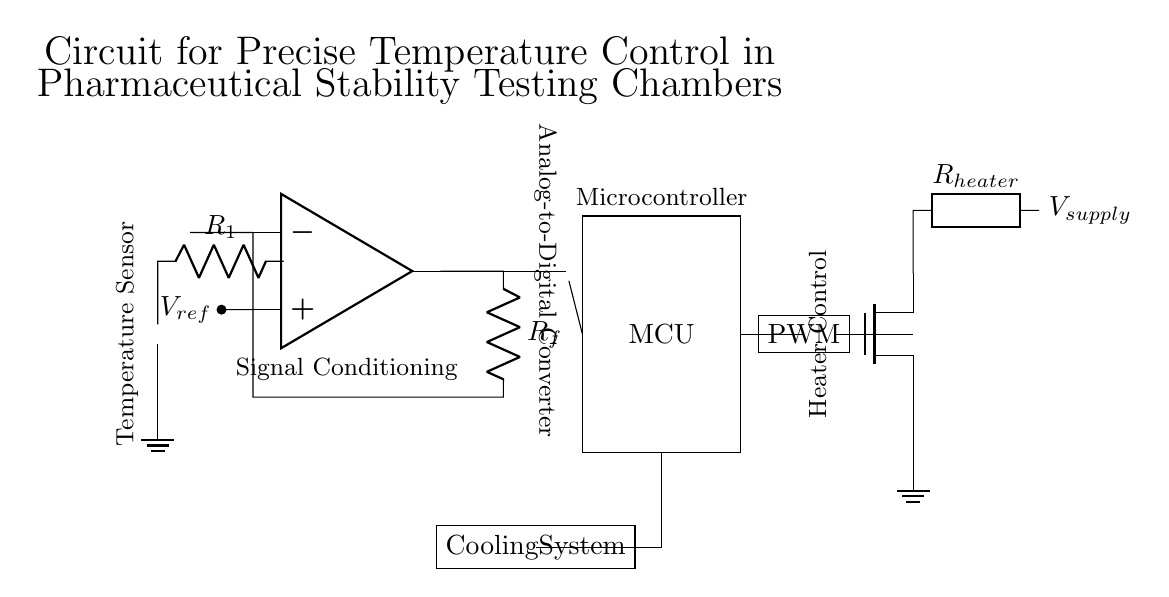What type of sensor is used in this circuit? The circuit employs a thermistor as the temperature sensor, which is indicated by the symbol used in the diagram.
Answer: Thermistor What component amplifies the signal from the sensor? The operational amplifier, designated as "op amp" in the diagram, is responsible for amplifying the signal received from the thermistor.
Answer: Op amp Which component converts the analog signal to digital? The ADC, or Analog-to-Digital Converter, converts the analog signal output from the operational amplifier into a digital format for processing by the microcontroller.
Answer: ADC What is the role of the PWM block in this circuit? The PWM, or Pulse Width Modulation, block controls the power sent to the heater based on the microcontroller's calculations to maintain the desired temperature.
Answer: Heater control If the reference voltage is 5 volts, what can be inferred about the feedback resistor? The feedback resistor is part of a feedback loop for the operational amplifier, assisting in determining the gain of the signal, which is calculated in tandem with the reference and input voltages. The specific value isn't provided in the diagram, only its function.
Answer: Feedback resistor value is unknown What is the purpose of the cooling system in this circuit? The cooling system is integrated to manage the temperature within the stability testing chamber by reducing the temperature when necessary, ensuring a controlled environment for pharmaceutical testing.
Answer: Temperature management How is power supplied to the heater in the circuit? The heater receives power directly from the supply voltage indicated as V supply in the diagram, through a MOSFET that acts as a switch controlled by the PWM signal.
Answer: V supply 